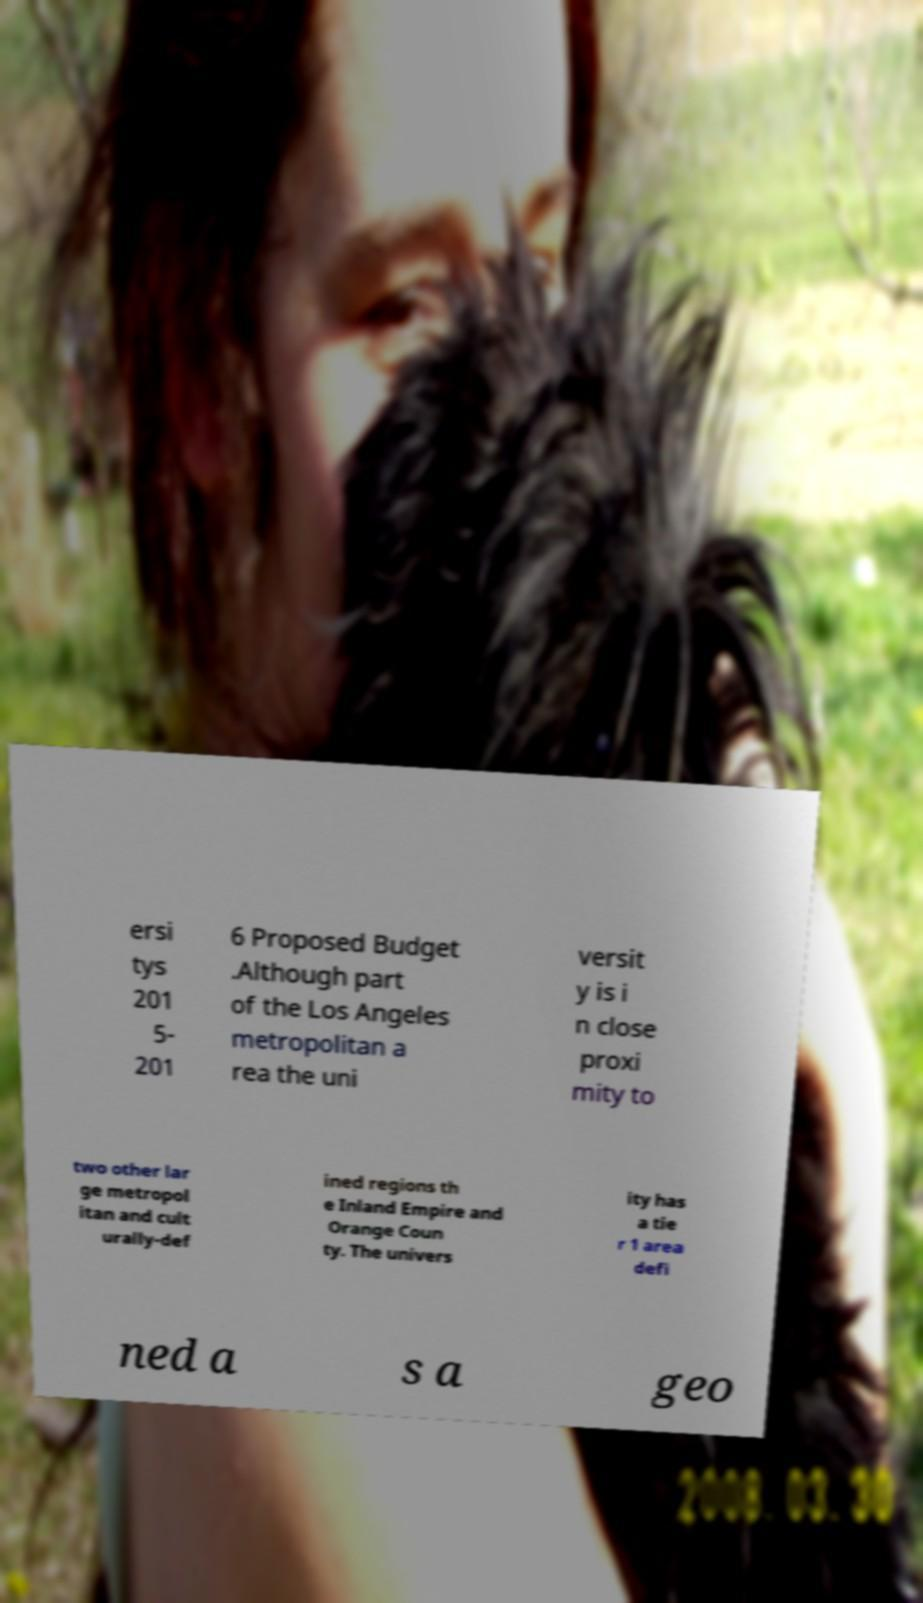Please read and relay the text visible in this image. What does it say? ersi tys 201 5- 201 6 Proposed Budget .Although part of the Los Angeles metropolitan a rea the uni versit y is i n close proxi mity to two other lar ge metropol itan and cult urally-def ined regions th e Inland Empire and Orange Coun ty. The univers ity has a tie r 1 area defi ned a s a geo 